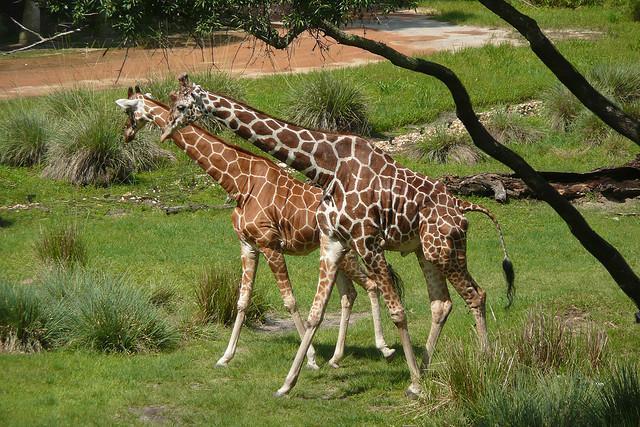How many animals are there?
Give a very brief answer. 2. How many giraffes?
Give a very brief answer. 2. How many giraffes are in this picture?
Give a very brief answer. 2. How many giraffes are there?
Give a very brief answer. 2. How many people are wearing red helmet?
Give a very brief answer. 0. 